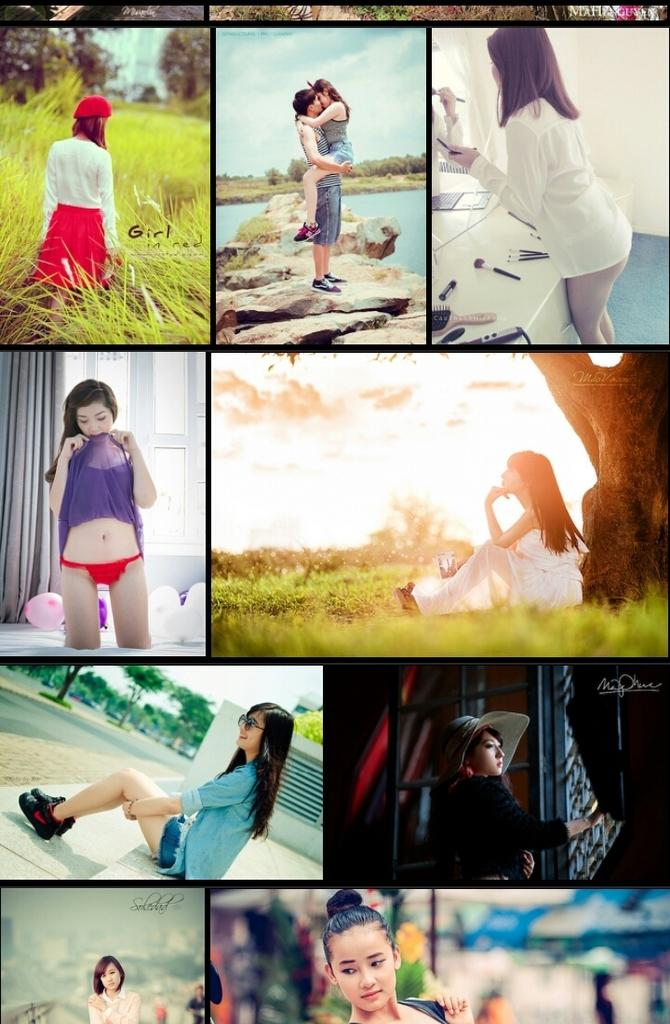How many people are present in the image? There is a man and women in the image, so there are at least two people present. What is the natural environment like in the image? The image features water, grass, trees, and rocks, suggesting a natural setting. What is visible in the sky in the image? The sky is visible in the image, and there are clouds present. What additional objects can be seen in the image? There are balloons in the image. What type of authority does the man in the image hold? There is no indication in the image of the man's authority or position. How many beds are visible in the image? There are no beds present in the image. 